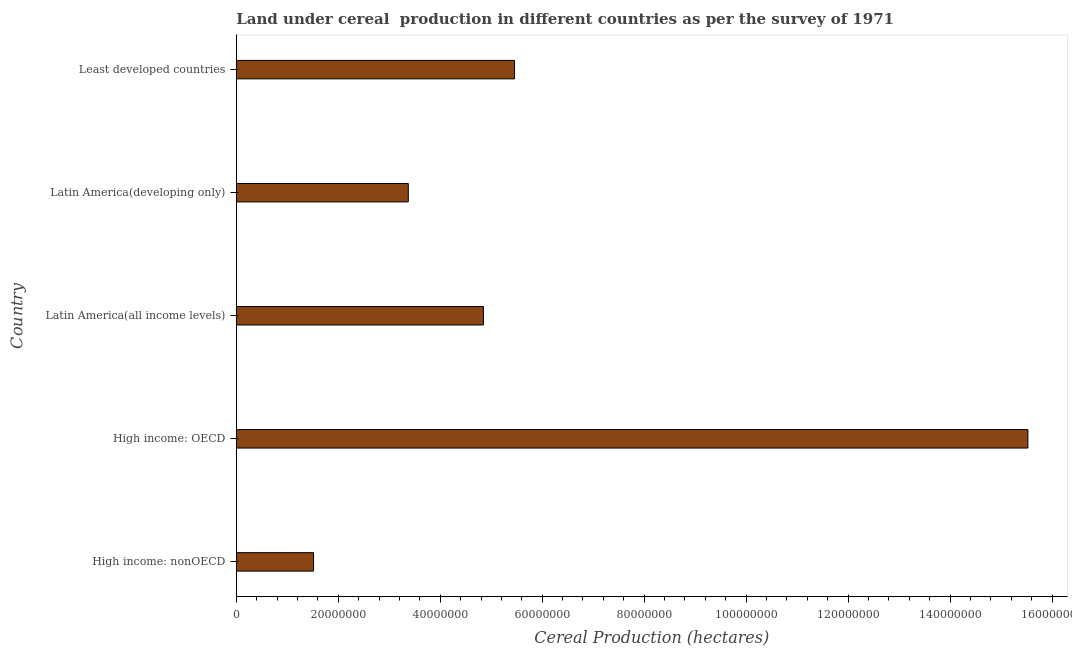Does the graph contain any zero values?
Make the answer very short. No. Does the graph contain grids?
Ensure brevity in your answer.  No. What is the title of the graph?
Your response must be concise. Land under cereal  production in different countries as per the survey of 1971. What is the label or title of the X-axis?
Ensure brevity in your answer.  Cereal Production (hectares). What is the land under cereal production in Latin America(all income levels)?
Your answer should be very brief. 4.85e+07. Across all countries, what is the maximum land under cereal production?
Your answer should be very brief. 1.55e+08. Across all countries, what is the minimum land under cereal production?
Provide a succinct answer. 1.52e+07. In which country was the land under cereal production maximum?
Offer a terse response. High income: OECD. In which country was the land under cereal production minimum?
Offer a very short reply. High income: nonOECD. What is the sum of the land under cereal production?
Ensure brevity in your answer.  3.07e+08. What is the difference between the land under cereal production in High income: nonOECD and Latin America(developing only)?
Your answer should be compact. -1.86e+07. What is the average land under cereal production per country?
Your response must be concise. 6.14e+07. What is the median land under cereal production?
Offer a very short reply. 4.85e+07. What is the ratio of the land under cereal production in High income: OECD to that in High income: nonOECD?
Provide a succinct answer. 10.24. Is the land under cereal production in Latin America(developing only) less than that in Least developed countries?
Your answer should be compact. Yes. What is the difference between the highest and the second highest land under cereal production?
Ensure brevity in your answer.  1.01e+08. Is the sum of the land under cereal production in High income: OECD and Latin America(all income levels) greater than the maximum land under cereal production across all countries?
Your answer should be very brief. Yes. What is the difference between the highest and the lowest land under cereal production?
Offer a very short reply. 1.40e+08. How many bars are there?
Ensure brevity in your answer.  5. Are the values on the major ticks of X-axis written in scientific E-notation?
Your answer should be very brief. No. What is the Cereal Production (hectares) of High income: nonOECD?
Keep it short and to the point. 1.52e+07. What is the Cereal Production (hectares) in High income: OECD?
Provide a succinct answer. 1.55e+08. What is the Cereal Production (hectares) in Latin America(all income levels)?
Make the answer very short. 4.85e+07. What is the Cereal Production (hectares) in Latin America(developing only)?
Provide a succinct answer. 3.37e+07. What is the Cereal Production (hectares) in Least developed countries?
Offer a terse response. 5.46e+07. What is the difference between the Cereal Production (hectares) in High income: nonOECD and High income: OECD?
Your answer should be very brief. -1.40e+08. What is the difference between the Cereal Production (hectares) in High income: nonOECD and Latin America(all income levels)?
Offer a very short reply. -3.33e+07. What is the difference between the Cereal Production (hectares) in High income: nonOECD and Latin America(developing only)?
Give a very brief answer. -1.86e+07. What is the difference between the Cereal Production (hectares) in High income: nonOECD and Least developed countries?
Provide a short and direct response. -3.94e+07. What is the difference between the Cereal Production (hectares) in High income: OECD and Latin America(all income levels)?
Provide a short and direct response. 1.07e+08. What is the difference between the Cereal Production (hectares) in High income: OECD and Latin America(developing only)?
Make the answer very short. 1.22e+08. What is the difference between the Cereal Production (hectares) in High income: OECD and Least developed countries?
Your answer should be compact. 1.01e+08. What is the difference between the Cereal Production (hectares) in Latin America(all income levels) and Latin America(developing only)?
Offer a very short reply. 1.47e+07. What is the difference between the Cereal Production (hectares) in Latin America(all income levels) and Least developed countries?
Make the answer very short. -6.10e+06. What is the difference between the Cereal Production (hectares) in Latin America(developing only) and Least developed countries?
Make the answer very short. -2.08e+07. What is the ratio of the Cereal Production (hectares) in High income: nonOECD to that in High income: OECD?
Your response must be concise. 0.1. What is the ratio of the Cereal Production (hectares) in High income: nonOECD to that in Latin America(all income levels)?
Your answer should be very brief. 0.31. What is the ratio of the Cereal Production (hectares) in High income: nonOECD to that in Latin America(developing only)?
Keep it short and to the point. 0.45. What is the ratio of the Cereal Production (hectares) in High income: nonOECD to that in Least developed countries?
Offer a terse response. 0.28. What is the ratio of the Cereal Production (hectares) in High income: OECD to that in Latin America(all income levels)?
Your answer should be very brief. 3.2. What is the ratio of the Cereal Production (hectares) in High income: OECD to that in Latin America(developing only)?
Provide a short and direct response. 4.6. What is the ratio of the Cereal Production (hectares) in High income: OECD to that in Least developed countries?
Provide a short and direct response. 2.85. What is the ratio of the Cereal Production (hectares) in Latin America(all income levels) to that in Latin America(developing only)?
Make the answer very short. 1.44. What is the ratio of the Cereal Production (hectares) in Latin America(all income levels) to that in Least developed countries?
Make the answer very short. 0.89. What is the ratio of the Cereal Production (hectares) in Latin America(developing only) to that in Least developed countries?
Keep it short and to the point. 0.62. 